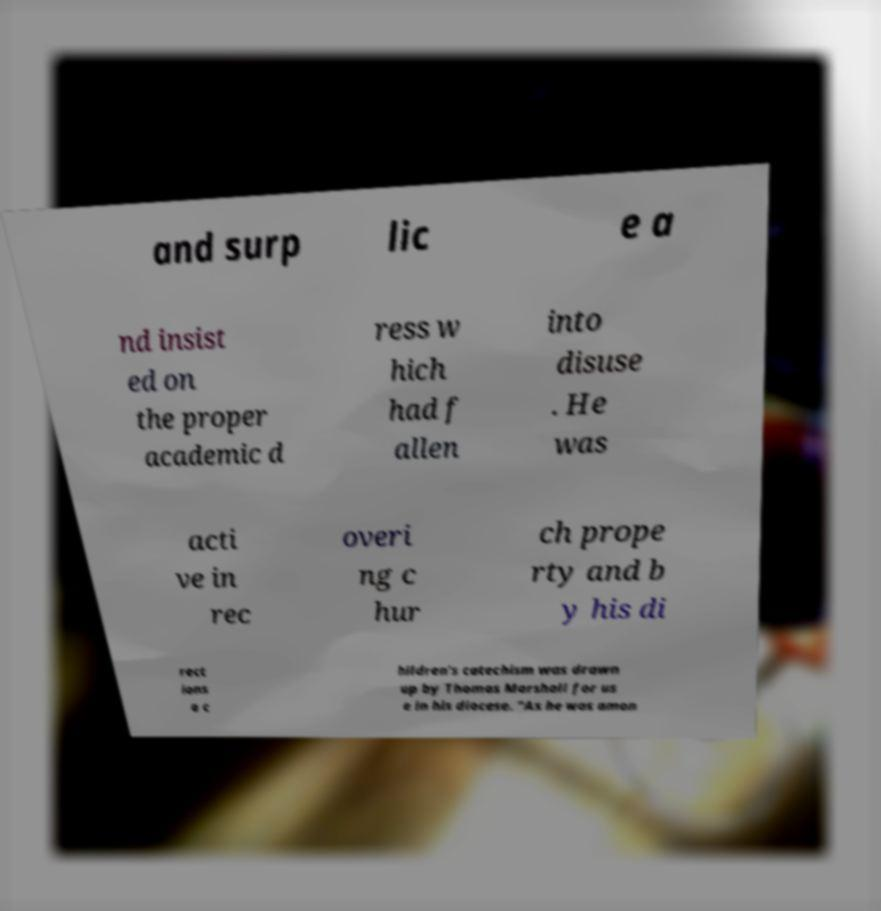Can you accurately transcribe the text from the provided image for me? and surp lic e a nd insist ed on the proper academic d ress w hich had f allen into disuse . He was acti ve in rec overi ng c hur ch prope rty and b y his di rect ions a c hildren's catechism was drawn up by Thomas Marshall for us e in his diocese. "As he was amon 